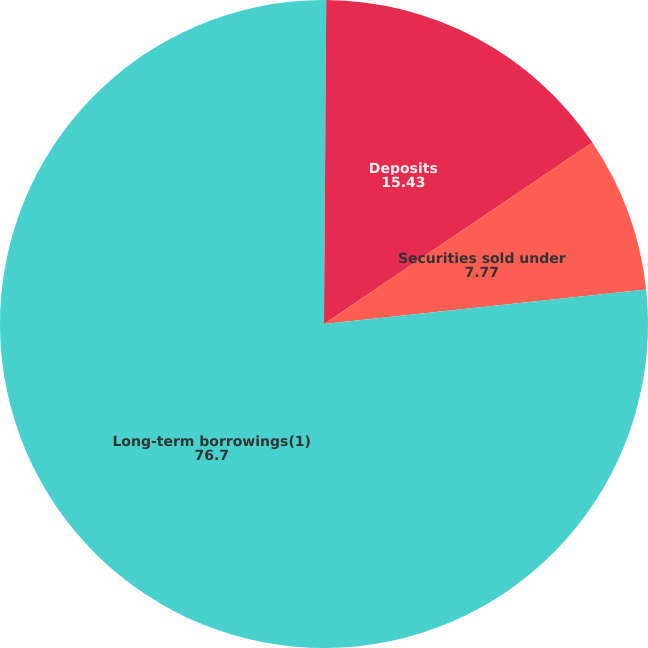<chart> <loc_0><loc_0><loc_500><loc_500><pie_chart><fcel>Federal funds sold and<fcel>Deposits<fcel>Securities sold under<fcel>Long-term borrowings(1)<nl><fcel>0.11%<fcel>15.43%<fcel>7.77%<fcel>76.7%<nl></chart> 